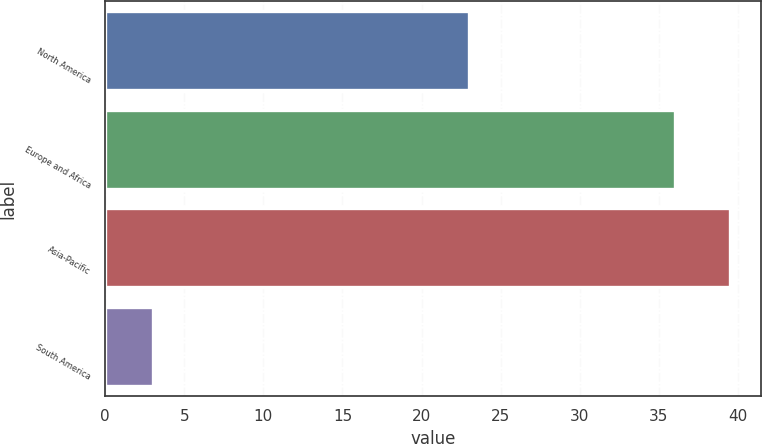<chart> <loc_0><loc_0><loc_500><loc_500><bar_chart><fcel>North America<fcel>Europe and Africa<fcel>Asia-Pacific<fcel>South America<nl><fcel>23<fcel>36<fcel>39.5<fcel>3<nl></chart> 